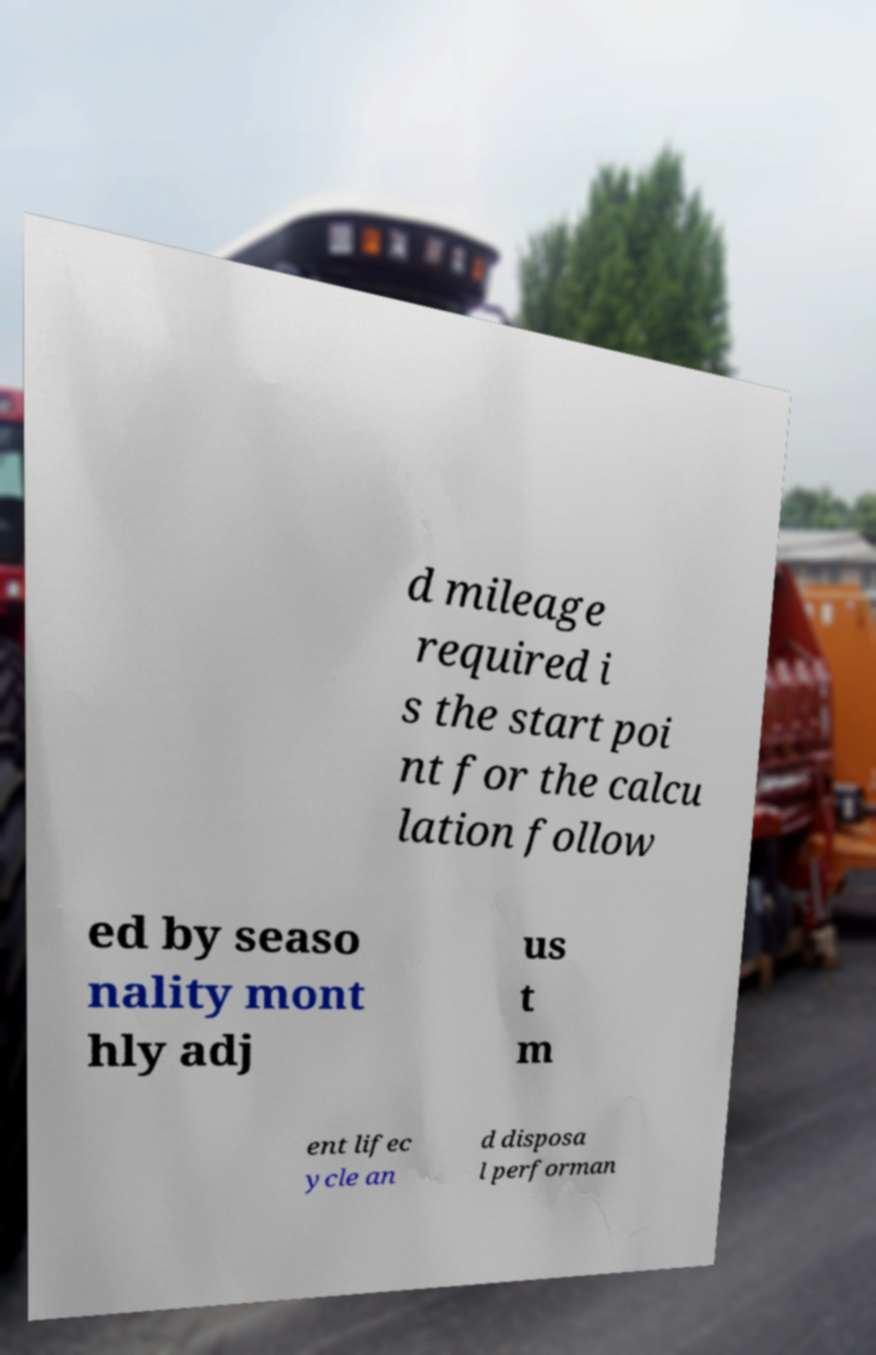Could you extract and type out the text from this image? d mileage required i s the start poi nt for the calcu lation follow ed by seaso nality mont hly adj us t m ent lifec ycle an d disposa l performan 